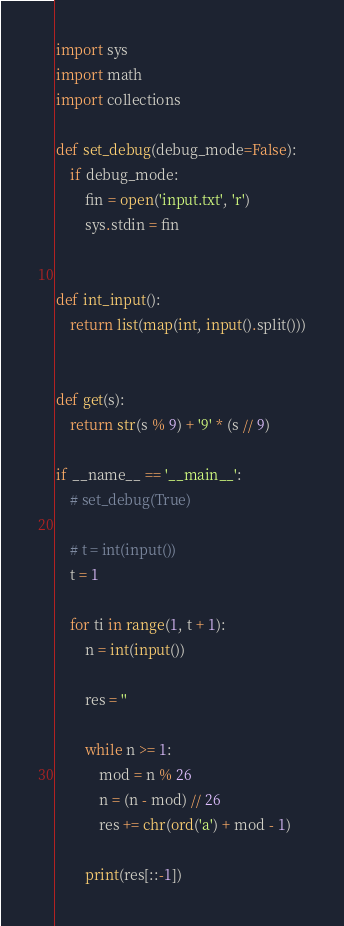<code> <loc_0><loc_0><loc_500><loc_500><_Python_>import sys
import math
import collections

def set_debug(debug_mode=False):
    if debug_mode:
        fin = open('input.txt', 'r')
        sys.stdin = fin


def int_input():
    return list(map(int, input().split()))


def get(s):
    return str(s % 9) + '9' * (s // 9)

if __name__ == '__main__':
    # set_debug(True)

    # t = int(input())
    t = 1

    for ti in range(1, t + 1):
        n = int(input())

        res = ''

        while n >= 1:
            mod = n % 26
            n = (n - mod) // 26
            res += chr(ord('a') + mod - 1)

        print(res[::-1])
</code> 